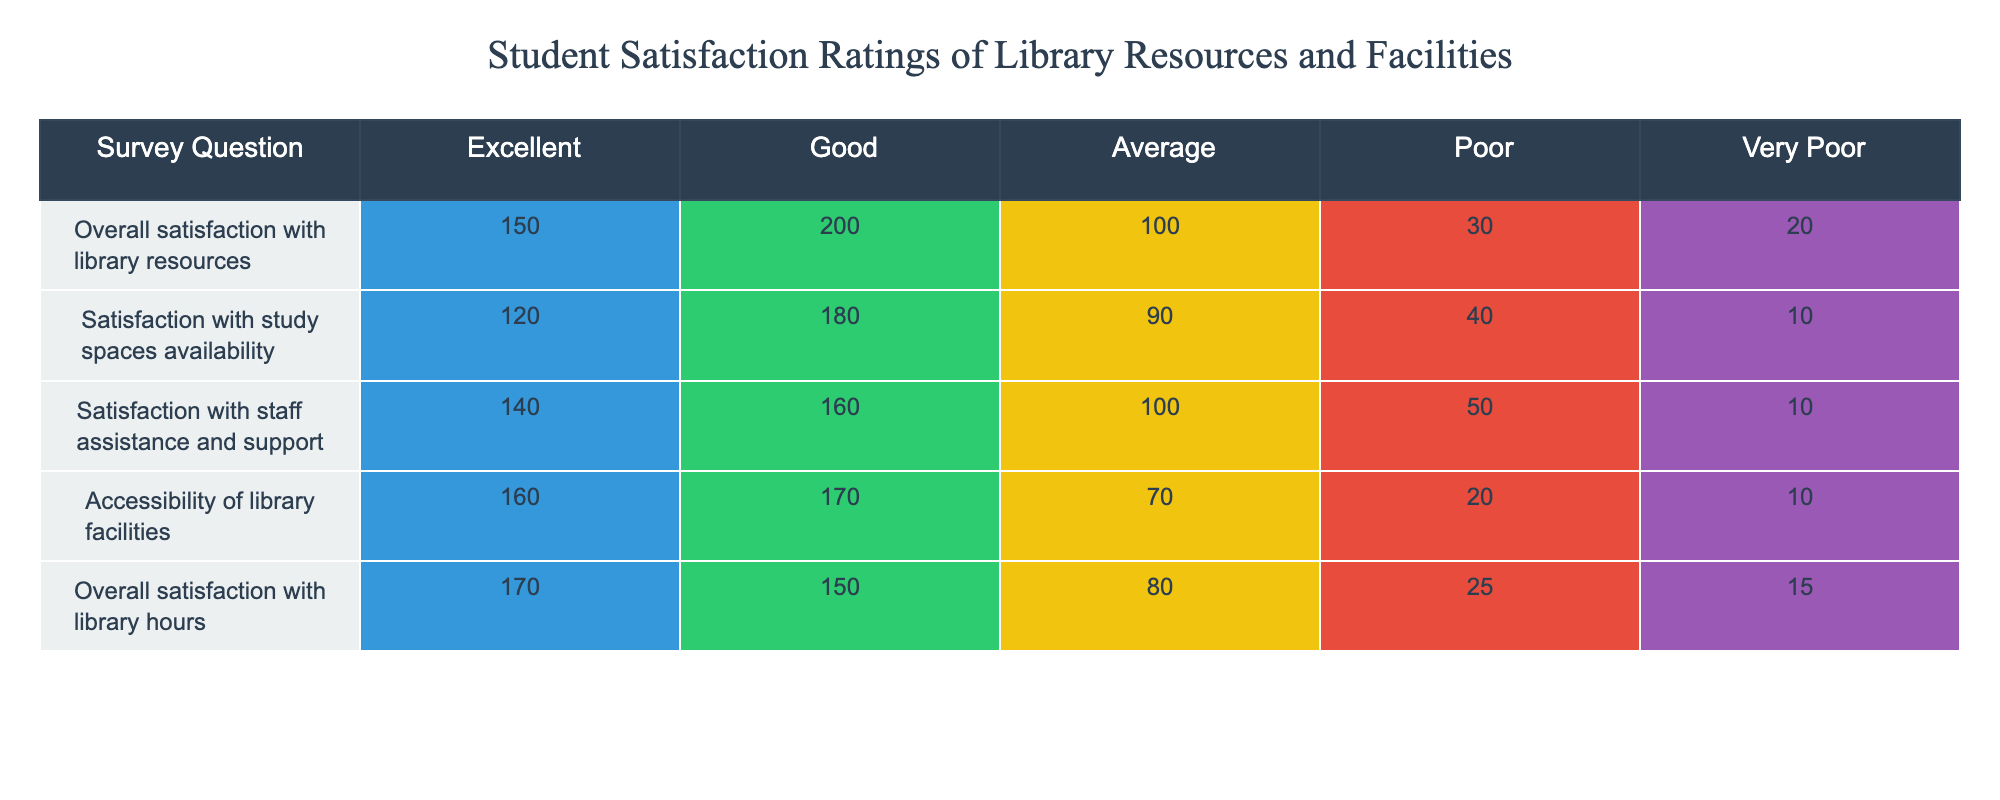What is the total number of respondents who rated the staff assistance and support as either Excellent or Good? To find the total for Excellent, we see 140 respondents rated it as Excellent, and for Good, it is 160. Adding these two values gives us (140 + 160) = 300 respondents.
Answer: 300 What percentage of respondents rated their overall satisfaction with library resources as Poor? The total number of respondents who rated their overall satisfaction with library resources is the sum of all ratings: (150 + 200 + 100 + 30 + 20) = 500. The number who rated it Poor is 30. To find the percentage, we calculate (30 / 500) * 100 = 6%.
Answer: 6% Is the satisfaction with study spaces availability rated higher than the accessibility of library facilities? For study spaces availability, the Excellent rating is 120, and for accessibility, it is 160. Comparing these, 120 is less than 160, which means study spaces availability is rated lower.
Answer: No What is the difference in the number of respondents who rated the overall library hours as Excellent versus those who rated them as Very Poor? The number of respondents who rated the library hours as Excellent is 170, and those who rated it as Very Poor is 15. The difference is calculated by subtracting: (170 - 15) = 155.
Answer: 155 Which resource received the highest overall satisfaction rating? By checking the Excellent ratings across all resources: Library hours have 170, resources have 150, study spaces have 120, staff support has 140, and accessibility has 160. The highest is Library hours with 170.
Answer: Library hours What is the average satisfaction rating across all categories for Excellent ratings? The Excellent ratings are: 150, 120, 140, 160, and 170. Adding these gives (150 + 120 + 140 + 160 + 170) = 840. There are 5 categories, so the average is 840 / 5 = 168.
Answer: 168 How many respondents rated the accessibility of library facilities as either Average or Poor? The number who rated accessibility as Average is 70 and as Poor is 20. Adding these two values gives us (70 + 20) = 90 respondents.
Answer: 90 Is there a larger number of respondents who rated the library resources as Excellent compared to both Good and Average combined? The Excellent rating is 150, the Good rating is 200, and Average is 100. Adding Good and Average together gives (200 + 100) = 300. Since 150 is less than 300, the statement is true.
Answer: No 